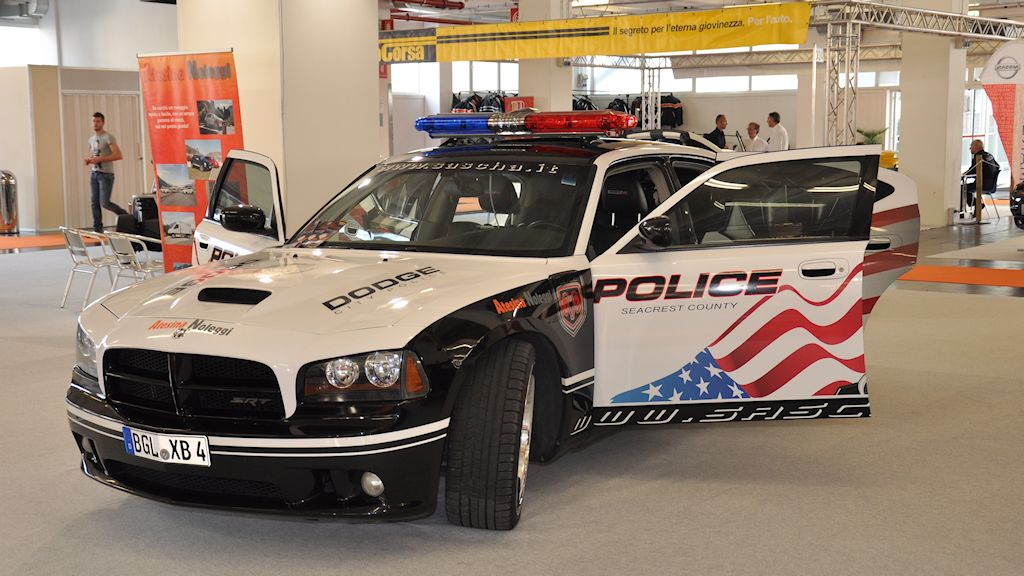How might this vehicle be utilized during a large-scale public event to ensure safety and security? During a large-scale public event such as a concert or parade, this vehicle would be strategically positioned in a highly visible location. Its bright graphics and flashing lights would serve as a deterrent to potential troublemakers. Officers could use the vehicle's advanced communication systems to coordinate with other units, effectively managing crowd control and swiftly addressing any incidents. Additionally, the car could facilitate quick responses to emergencies, navigating through crowds with ease due to its design and equipment. Its role would be to maintain a reassuring presence, ensuring attendees feel safe and well-protected throughout the event. 